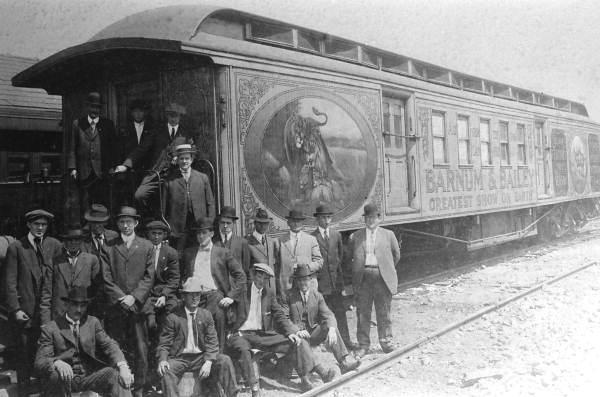How many people are in the picture?
Give a very brief answer. 11. How many trains are there?
Give a very brief answer. 2. 